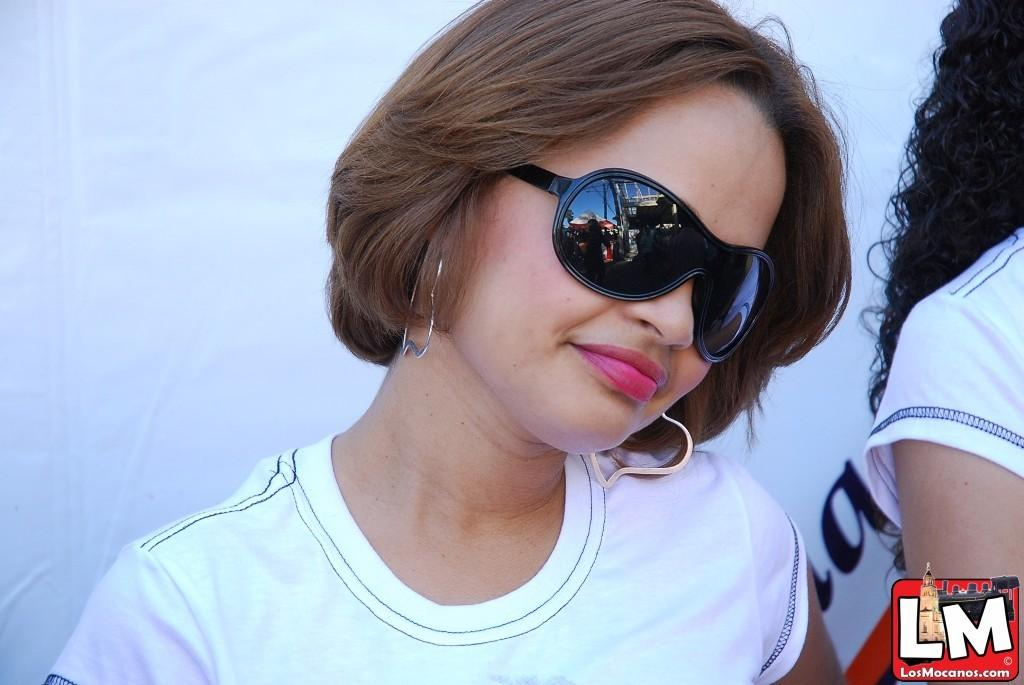How many people are in the image? There are people in the image, but the exact number is not specified. What is one person wearing in the image? One person is wearing goggles in the image. What can be seen in the background of the image? There is a banner in the background of the image. What is located at the bottom of the image? There is a logo at the bottom of the image. What type of structure can be seen housing a flock of birds in the image? There is no structure housing a flock of birds present in the image. 